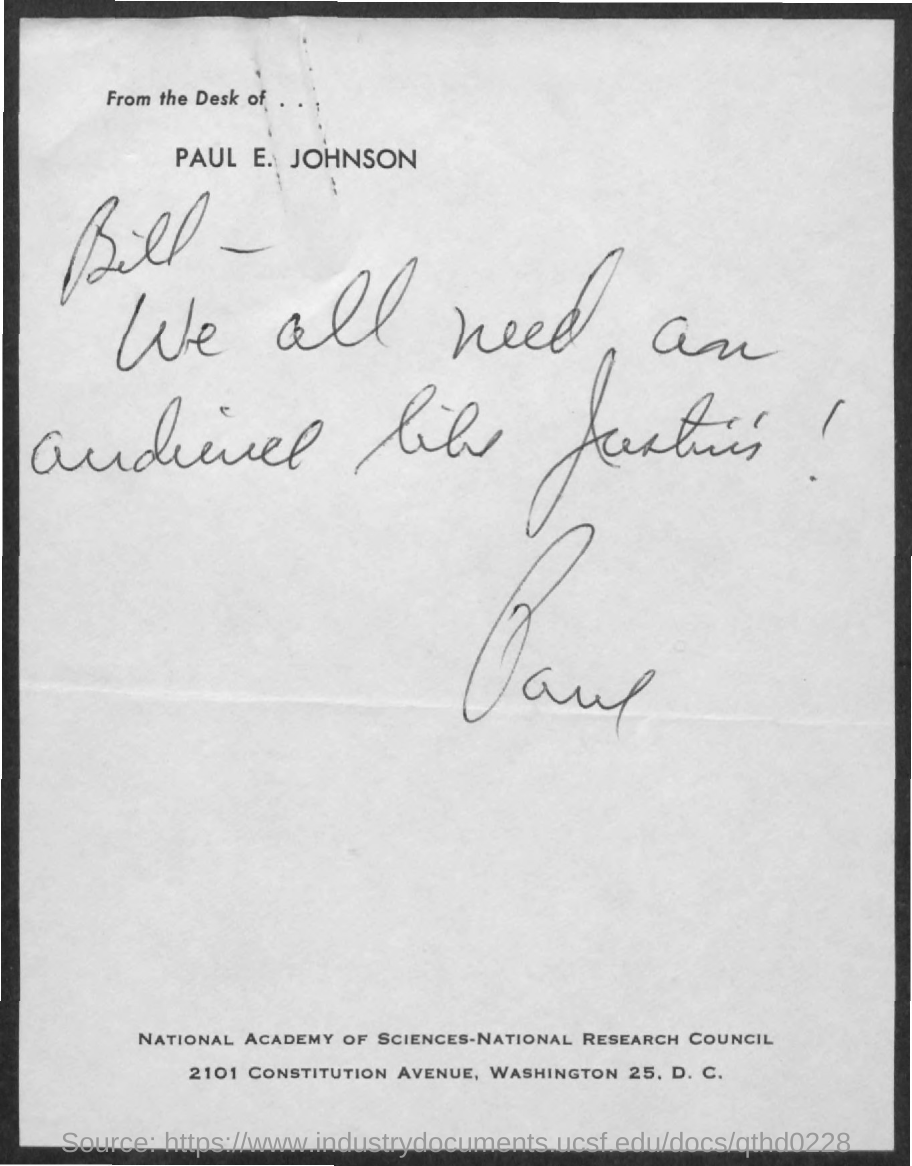Who is the note addressed to?
Your answer should be very brief. Bill. 